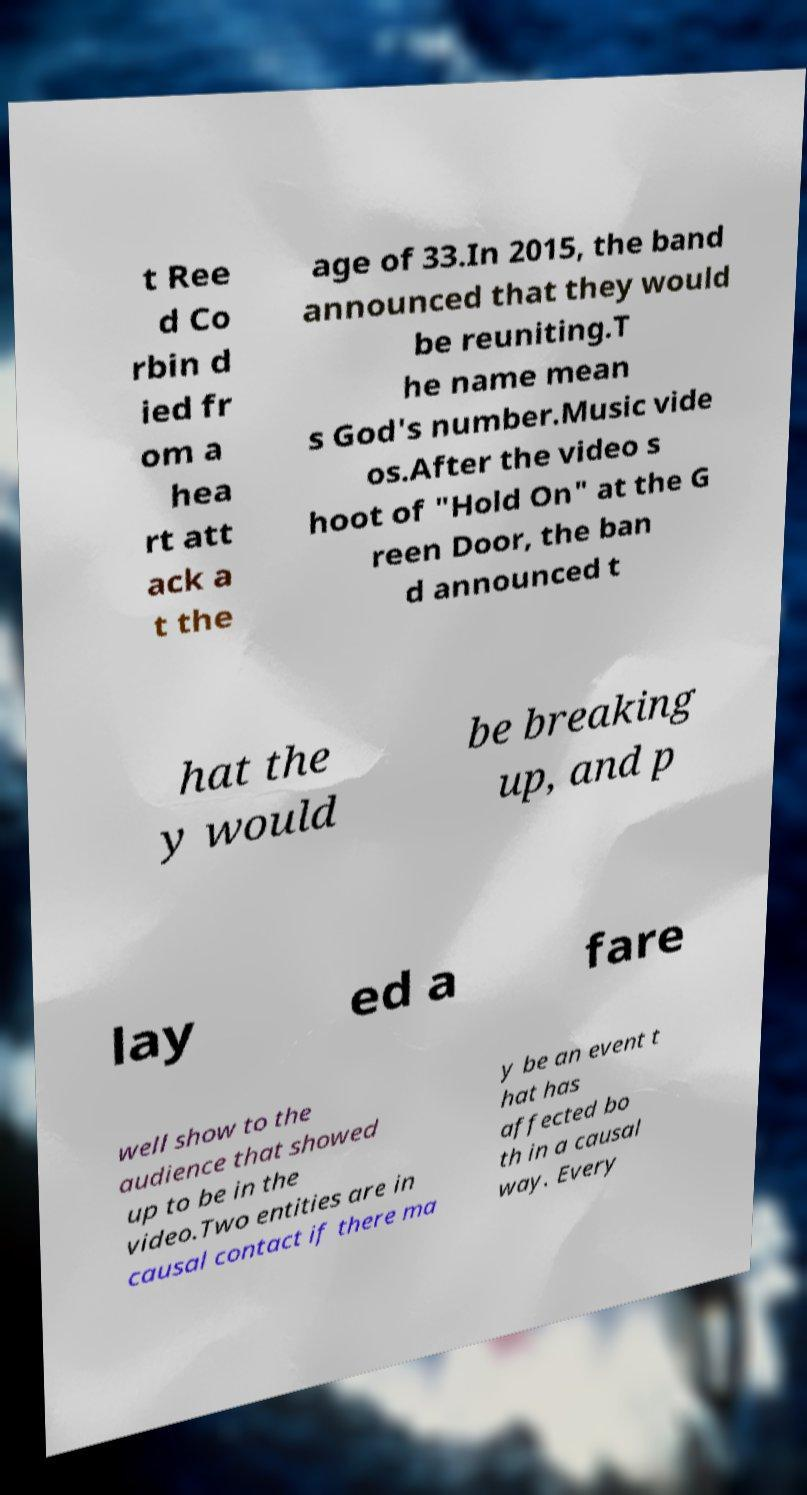What messages or text are displayed in this image? I need them in a readable, typed format. t Ree d Co rbin d ied fr om a hea rt att ack a t the age of 33.In 2015, the band announced that they would be reuniting.T he name mean s God's number.Music vide os.After the video s hoot of "Hold On" at the G reen Door, the ban d announced t hat the y would be breaking up, and p lay ed a fare well show to the audience that showed up to be in the video.Two entities are in causal contact if there ma y be an event t hat has affected bo th in a causal way. Every 